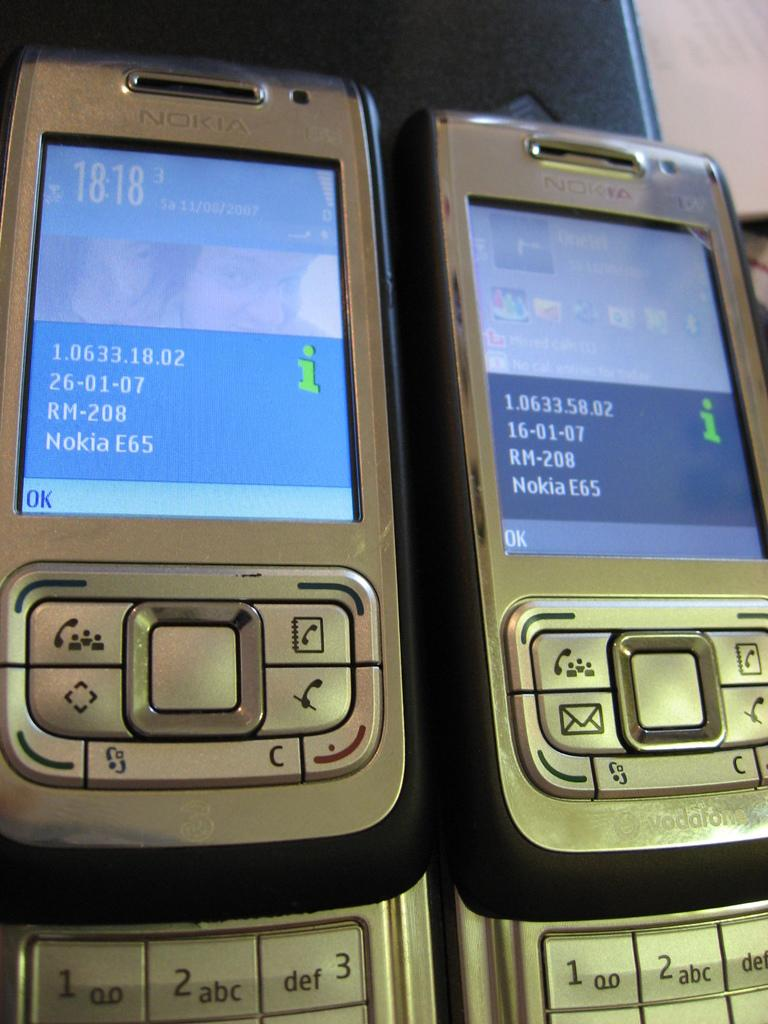<image>
Offer a succinct explanation of the picture presented. Two Nokia brand phones sit side by side. 